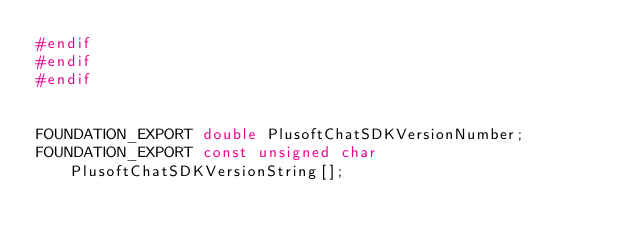<code> <loc_0><loc_0><loc_500><loc_500><_C_>#endif
#endif
#endif


FOUNDATION_EXPORT double PlusoftChatSDKVersionNumber;
FOUNDATION_EXPORT const unsigned char PlusoftChatSDKVersionString[];

</code> 